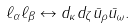<formula> <loc_0><loc_0><loc_500><loc_500>\ell _ { \alpha } \ell _ { \beta } \leftrightarrow d _ { \kappa } d _ { \zeta } \bar { u } _ { \rho } \bar { u } _ { \omega } .</formula> 